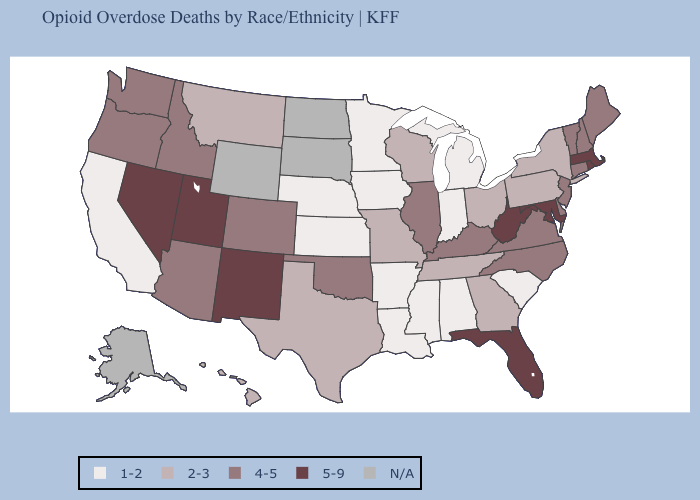What is the value of Idaho?
Short answer required. 4-5. Among the states that border South Carolina , does North Carolina have the highest value?
Concise answer only. Yes. How many symbols are there in the legend?
Quick response, please. 5. Does Arkansas have the lowest value in the South?
Short answer required. Yes. Which states have the lowest value in the Northeast?
Quick response, please. New York, Pennsylvania. What is the value of California?
Give a very brief answer. 1-2. What is the value of Minnesota?
Write a very short answer. 1-2. Name the states that have a value in the range 5-9?
Quick response, please. Florida, Maryland, Massachusetts, Nevada, New Mexico, Rhode Island, Utah, West Virginia. What is the lowest value in the South?
Keep it brief. 1-2. Does California have the highest value in the USA?
Give a very brief answer. No. Is the legend a continuous bar?
Be succinct. No. What is the value of New York?
Give a very brief answer. 2-3. What is the value of North Carolina?
Answer briefly. 4-5. What is the highest value in the Northeast ?
Quick response, please. 5-9. Among the states that border Louisiana , does Arkansas have the lowest value?
Be succinct. Yes. 